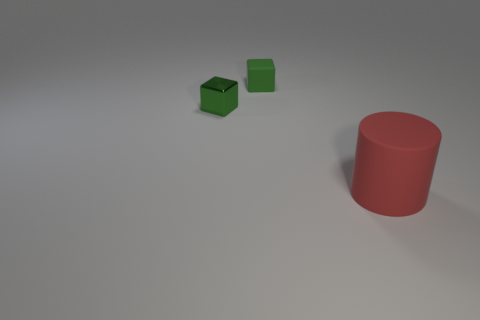Add 1 large gray matte blocks. How many objects exist? 4 Subtract all blocks. How many objects are left? 1 Subtract 0 purple cylinders. How many objects are left? 3 Subtract all tiny shiny objects. Subtract all tiny metallic things. How many objects are left? 1 Add 3 objects. How many objects are left? 6 Add 1 green metal objects. How many green metal objects exist? 2 